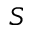<formula> <loc_0><loc_0><loc_500><loc_500>S</formula> 